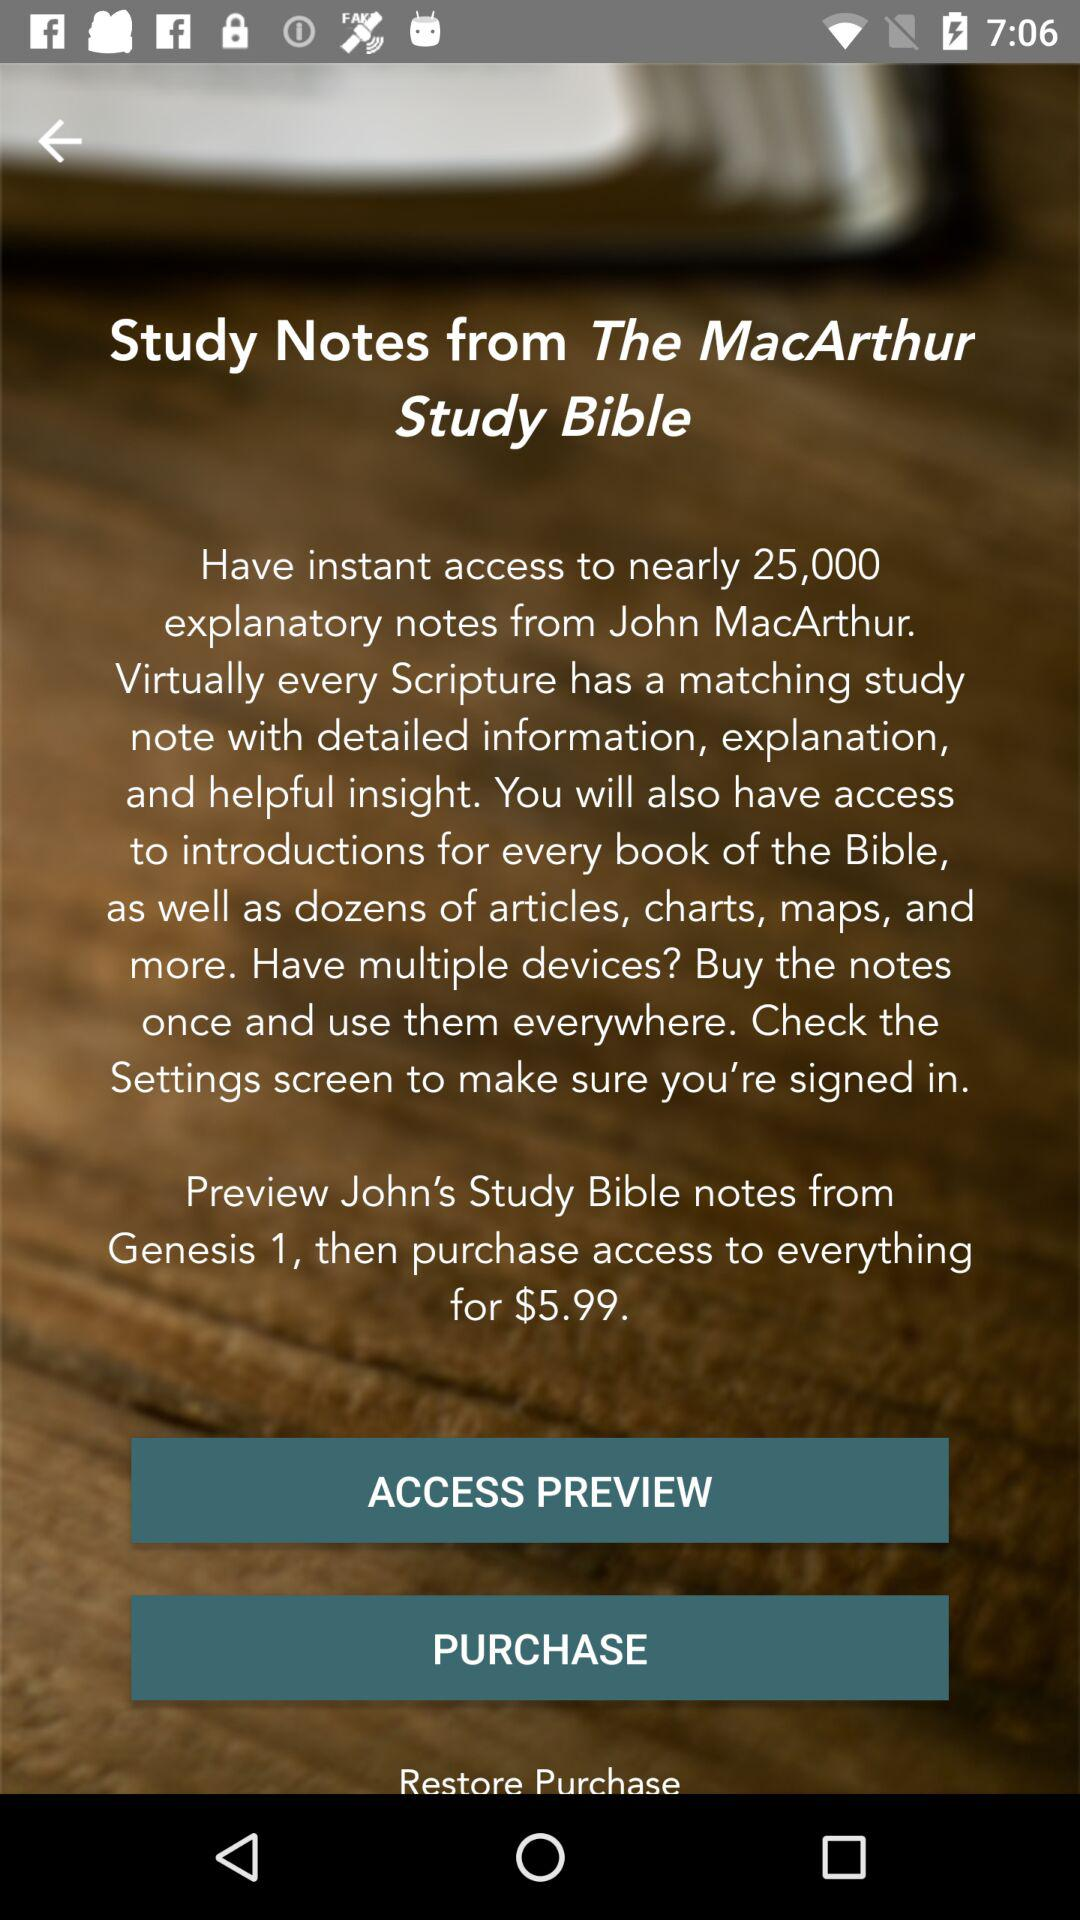Is the application purchased?
When the provided information is insufficient, respond with <no answer>. <no answer> 